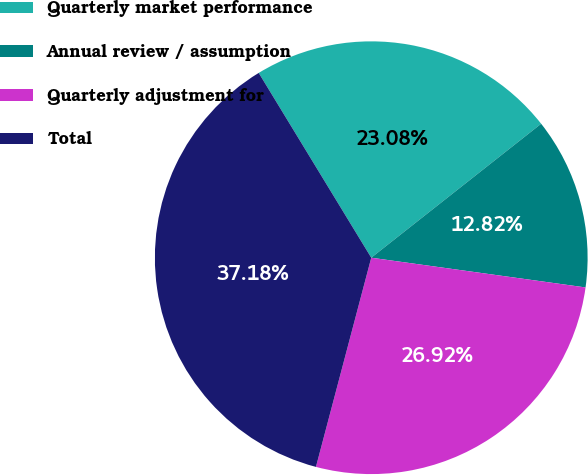Convert chart. <chart><loc_0><loc_0><loc_500><loc_500><pie_chart><fcel>Quarterly market performance<fcel>Annual review / assumption<fcel>Quarterly adjustment for<fcel>Total<nl><fcel>23.08%<fcel>12.82%<fcel>26.92%<fcel>37.18%<nl></chart> 